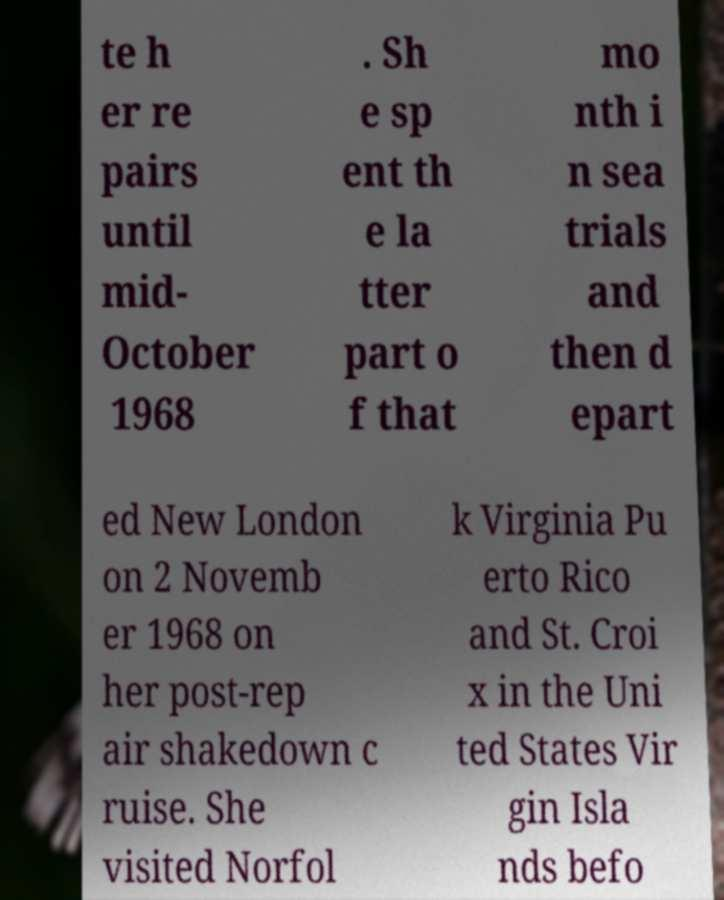What messages or text are displayed in this image? I need them in a readable, typed format. te h er re pairs until mid- October 1968 . Sh e sp ent th e la tter part o f that mo nth i n sea trials and then d epart ed New London on 2 Novemb er 1968 on her post-rep air shakedown c ruise. She visited Norfol k Virginia Pu erto Rico and St. Croi x in the Uni ted States Vir gin Isla nds befo 